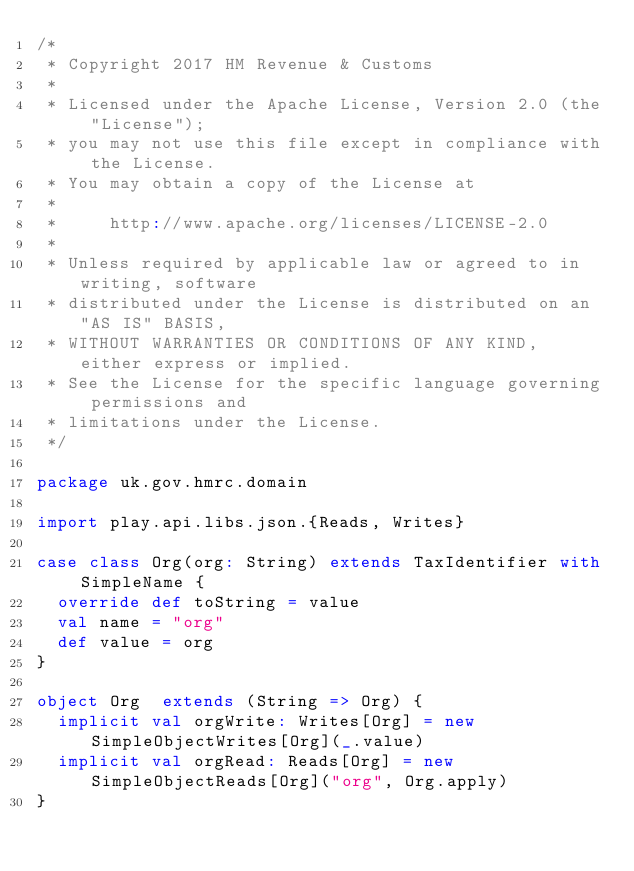Convert code to text. <code><loc_0><loc_0><loc_500><loc_500><_Scala_>/*
 * Copyright 2017 HM Revenue & Customs
 *
 * Licensed under the Apache License, Version 2.0 (the "License");
 * you may not use this file except in compliance with the License.
 * You may obtain a copy of the License at
 *
 *     http://www.apache.org/licenses/LICENSE-2.0
 *
 * Unless required by applicable law or agreed to in writing, software
 * distributed under the License is distributed on an "AS IS" BASIS,
 * WITHOUT WARRANTIES OR CONDITIONS OF ANY KIND, either express or implied.
 * See the License for the specific language governing permissions and
 * limitations under the License.
 */

package uk.gov.hmrc.domain

import play.api.libs.json.{Reads, Writes}

case class Org(org: String) extends TaxIdentifier with SimpleName {
  override def toString = value
  val name = "org"
  def value = org
}

object Org  extends (String => Org) {
  implicit val orgWrite: Writes[Org] = new SimpleObjectWrites[Org](_.value)
  implicit val orgRead: Reads[Org] = new SimpleObjectReads[Org]("org", Org.apply)
}
</code> 